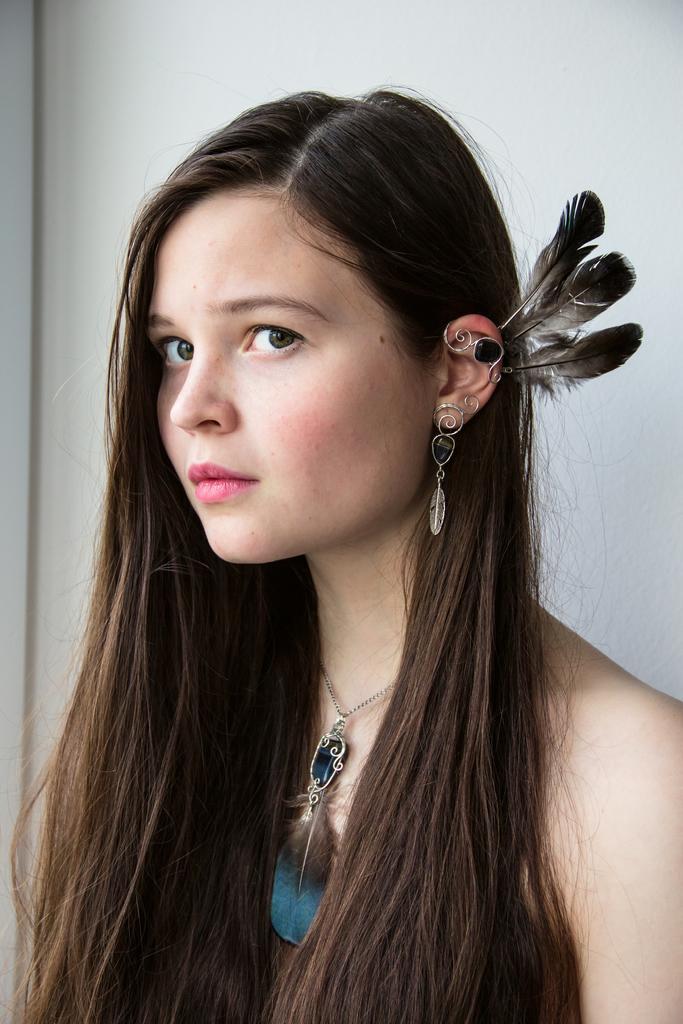In one or two sentences, can you explain what this image depicts? Here I can see a woman is giving pose for the picture. I can see a locket to her neck. In the background there is a wall. 